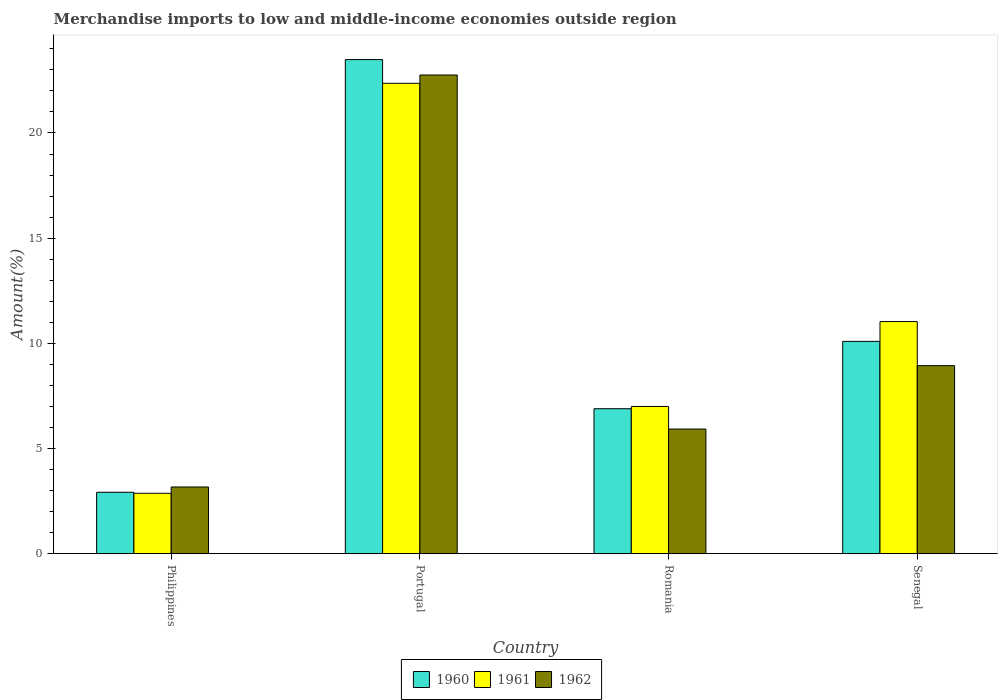Are the number of bars on each tick of the X-axis equal?
Your answer should be compact. Yes. What is the label of the 2nd group of bars from the left?
Your answer should be compact. Portugal. What is the percentage of amount earned from merchandise imports in 1962 in Portugal?
Ensure brevity in your answer.  22.76. Across all countries, what is the maximum percentage of amount earned from merchandise imports in 1960?
Give a very brief answer. 23.49. Across all countries, what is the minimum percentage of amount earned from merchandise imports in 1961?
Provide a succinct answer. 2.87. In which country was the percentage of amount earned from merchandise imports in 1960 minimum?
Offer a very short reply. Philippines. What is the total percentage of amount earned from merchandise imports in 1962 in the graph?
Provide a succinct answer. 40.79. What is the difference between the percentage of amount earned from merchandise imports in 1962 in Philippines and that in Romania?
Offer a very short reply. -2.75. What is the difference between the percentage of amount earned from merchandise imports in 1962 in Portugal and the percentage of amount earned from merchandise imports in 1960 in Philippines?
Ensure brevity in your answer.  19.84. What is the average percentage of amount earned from merchandise imports in 1961 per country?
Make the answer very short. 10.82. What is the difference between the percentage of amount earned from merchandise imports of/in 1961 and percentage of amount earned from merchandise imports of/in 1962 in Portugal?
Ensure brevity in your answer.  -0.39. In how many countries, is the percentage of amount earned from merchandise imports in 1961 greater than 23 %?
Offer a very short reply. 0. What is the ratio of the percentage of amount earned from merchandise imports in 1961 in Portugal to that in Senegal?
Provide a short and direct response. 2.03. What is the difference between the highest and the second highest percentage of amount earned from merchandise imports in 1961?
Ensure brevity in your answer.  -11.33. What is the difference between the highest and the lowest percentage of amount earned from merchandise imports in 1960?
Make the answer very short. 20.57. In how many countries, is the percentage of amount earned from merchandise imports in 1960 greater than the average percentage of amount earned from merchandise imports in 1960 taken over all countries?
Offer a very short reply. 1. Is the sum of the percentage of amount earned from merchandise imports in 1961 in Portugal and Senegal greater than the maximum percentage of amount earned from merchandise imports in 1960 across all countries?
Your response must be concise. Yes. Is it the case that in every country, the sum of the percentage of amount earned from merchandise imports in 1962 and percentage of amount earned from merchandise imports in 1960 is greater than the percentage of amount earned from merchandise imports in 1961?
Give a very brief answer. Yes. How many bars are there?
Make the answer very short. 12. Are all the bars in the graph horizontal?
Provide a succinct answer. No. How many countries are there in the graph?
Your answer should be very brief. 4. Are the values on the major ticks of Y-axis written in scientific E-notation?
Your response must be concise. No. Where does the legend appear in the graph?
Provide a short and direct response. Bottom center. What is the title of the graph?
Make the answer very short. Merchandise imports to low and middle-income economies outside region. What is the label or title of the Y-axis?
Your answer should be compact. Amount(%). What is the Amount(%) of 1960 in Philippines?
Ensure brevity in your answer.  2.92. What is the Amount(%) in 1961 in Philippines?
Offer a very short reply. 2.87. What is the Amount(%) of 1962 in Philippines?
Your answer should be very brief. 3.17. What is the Amount(%) in 1960 in Portugal?
Give a very brief answer. 23.49. What is the Amount(%) of 1961 in Portugal?
Give a very brief answer. 22.36. What is the Amount(%) of 1962 in Portugal?
Give a very brief answer. 22.76. What is the Amount(%) of 1960 in Romania?
Make the answer very short. 6.89. What is the Amount(%) in 1961 in Romania?
Provide a succinct answer. 7. What is the Amount(%) in 1962 in Romania?
Give a very brief answer. 5.92. What is the Amount(%) of 1960 in Senegal?
Ensure brevity in your answer.  10.09. What is the Amount(%) in 1961 in Senegal?
Make the answer very short. 11.03. What is the Amount(%) in 1962 in Senegal?
Offer a very short reply. 8.94. Across all countries, what is the maximum Amount(%) in 1960?
Keep it short and to the point. 23.49. Across all countries, what is the maximum Amount(%) in 1961?
Give a very brief answer. 22.36. Across all countries, what is the maximum Amount(%) in 1962?
Provide a short and direct response. 22.76. Across all countries, what is the minimum Amount(%) of 1960?
Your response must be concise. 2.92. Across all countries, what is the minimum Amount(%) of 1961?
Give a very brief answer. 2.87. Across all countries, what is the minimum Amount(%) of 1962?
Provide a succinct answer. 3.17. What is the total Amount(%) in 1960 in the graph?
Make the answer very short. 43.39. What is the total Amount(%) in 1961 in the graph?
Ensure brevity in your answer.  43.26. What is the total Amount(%) of 1962 in the graph?
Provide a succinct answer. 40.79. What is the difference between the Amount(%) of 1960 in Philippines and that in Portugal?
Give a very brief answer. -20.57. What is the difference between the Amount(%) in 1961 in Philippines and that in Portugal?
Your answer should be very brief. -19.49. What is the difference between the Amount(%) in 1962 in Philippines and that in Portugal?
Your response must be concise. -19.59. What is the difference between the Amount(%) of 1960 in Philippines and that in Romania?
Give a very brief answer. -3.97. What is the difference between the Amount(%) in 1961 in Philippines and that in Romania?
Your answer should be compact. -4.13. What is the difference between the Amount(%) of 1962 in Philippines and that in Romania?
Provide a short and direct response. -2.75. What is the difference between the Amount(%) in 1960 in Philippines and that in Senegal?
Ensure brevity in your answer.  -7.17. What is the difference between the Amount(%) of 1961 in Philippines and that in Senegal?
Provide a short and direct response. -8.16. What is the difference between the Amount(%) in 1962 in Philippines and that in Senegal?
Offer a very short reply. -5.77. What is the difference between the Amount(%) in 1960 in Portugal and that in Romania?
Your answer should be very brief. 16.6. What is the difference between the Amount(%) of 1961 in Portugal and that in Romania?
Ensure brevity in your answer.  15.36. What is the difference between the Amount(%) in 1962 in Portugal and that in Romania?
Keep it short and to the point. 16.83. What is the difference between the Amount(%) of 1960 in Portugal and that in Senegal?
Provide a succinct answer. 13.4. What is the difference between the Amount(%) in 1961 in Portugal and that in Senegal?
Provide a succinct answer. 11.33. What is the difference between the Amount(%) of 1962 in Portugal and that in Senegal?
Provide a short and direct response. 13.82. What is the difference between the Amount(%) of 1960 in Romania and that in Senegal?
Your response must be concise. -3.2. What is the difference between the Amount(%) of 1961 in Romania and that in Senegal?
Your answer should be compact. -4.04. What is the difference between the Amount(%) in 1962 in Romania and that in Senegal?
Offer a very short reply. -3.01. What is the difference between the Amount(%) in 1960 in Philippines and the Amount(%) in 1961 in Portugal?
Offer a terse response. -19.44. What is the difference between the Amount(%) in 1960 in Philippines and the Amount(%) in 1962 in Portugal?
Your answer should be very brief. -19.84. What is the difference between the Amount(%) of 1961 in Philippines and the Amount(%) of 1962 in Portugal?
Your response must be concise. -19.89. What is the difference between the Amount(%) of 1960 in Philippines and the Amount(%) of 1961 in Romania?
Offer a terse response. -4.08. What is the difference between the Amount(%) of 1960 in Philippines and the Amount(%) of 1962 in Romania?
Offer a very short reply. -3.01. What is the difference between the Amount(%) in 1961 in Philippines and the Amount(%) in 1962 in Romania?
Give a very brief answer. -3.05. What is the difference between the Amount(%) in 1960 in Philippines and the Amount(%) in 1961 in Senegal?
Ensure brevity in your answer.  -8.12. What is the difference between the Amount(%) of 1960 in Philippines and the Amount(%) of 1962 in Senegal?
Your answer should be compact. -6.02. What is the difference between the Amount(%) of 1961 in Philippines and the Amount(%) of 1962 in Senegal?
Give a very brief answer. -6.07. What is the difference between the Amount(%) in 1960 in Portugal and the Amount(%) in 1961 in Romania?
Provide a short and direct response. 16.49. What is the difference between the Amount(%) in 1960 in Portugal and the Amount(%) in 1962 in Romania?
Give a very brief answer. 17.56. What is the difference between the Amount(%) of 1961 in Portugal and the Amount(%) of 1962 in Romania?
Your answer should be compact. 16.44. What is the difference between the Amount(%) of 1960 in Portugal and the Amount(%) of 1961 in Senegal?
Offer a very short reply. 12.45. What is the difference between the Amount(%) of 1960 in Portugal and the Amount(%) of 1962 in Senegal?
Provide a short and direct response. 14.55. What is the difference between the Amount(%) of 1961 in Portugal and the Amount(%) of 1962 in Senegal?
Your answer should be very brief. 13.42. What is the difference between the Amount(%) of 1960 in Romania and the Amount(%) of 1961 in Senegal?
Provide a short and direct response. -4.14. What is the difference between the Amount(%) of 1960 in Romania and the Amount(%) of 1962 in Senegal?
Provide a short and direct response. -2.05. What is the difference between the Amount(%) of 1961 in Romania and the Amount(%) of 1962 in Senegal?
Make the answer very short. -1.94. What is the average Amount(%) of 1960 per country?
Give a very brief answer. 10.85. What is the average Amount(%) of 1961 per country?
Give a very brief answer. 10.82. What is the average Amount(%) of 1962 per country?
Provide a short and direct response. 10.2. What is the difference between the Amount(%) in 1960 and Amount(%) in 1961 in Philippines?
Offer a very short reply. 0.05. What is the difference between the Amount(%) of 1960 and Amount(%) of 1962 in Philippines?
Your answer should be very brief. -0.25. What is the difference between the Amount(%) in 1961 and Amount(%) in 1962 in Philippines?
Ensure brevity in your answer.  -0.3. What is the difference between the Amount(%) in 1960 and Amount(%) in 1961 in Portugal?
Keep it short and to the point. 1.13. What is the difference between the Amount(%) in 1960 and Amount(%) in 1962 in Portugal?
Ensure brevity in your answer.  0.73. What is the difference between the Amount(%) of 1961 and Amount(%) of 1962 in Portugal?
Offer a terse response. -0.39. What is the difference between the Amount(%) in 1960 and Amount(%) in 1961 in Romania?
Keep it short and to the point. -0.11. What is the difference between the Amount(%) of 1960 and Amount(%) of 1962 in Romania?
Your answer should be compact. 0.97. What is the difference between the Amount(%) of 1961 and Amount(%) of 1962 in Romania?
Offer a very short reply. 1.07. What is the difference between the Amount(%) in 1960 and Amount(%) in 1961 in Senegal?
Make the answer very short. -0.94. What is the difference between the Amount(%) in 1960 and Amount(%) in 1962 in Senegal?
Your answer should be compact. 1.16. What is the difference between the Amount(%) in 1961 and Amount(%) in 1962 in Senegal?
Offer a terse response. 2.1. What is the ratio of the Amount(%) of 1960 in Philippines to that in Portugal?
Provide a succinct answer. 0.12. What is the ratio of the Amount(%) in 1961 in Philippines to that in Portugal?
Give a very brief answer. 0.13. What is the ratio of the Amount(%) of 1962 in Philippines to that in Portugal?
Your answer should be very brief. 0.14. What is the ratio of the Amount(%) of 1960 in Philippines to that in Romania?
Your answer should be compact. 0.42. What is the ratio of the Amount(%) of 1961 in Philippines to that in Romania?
Provide a succinct answer. 0.41. What is the ratio of the Amount(%) in 1962 in Philippines to that in Romania?
Your answer should be very brief. 0.54. What is the ratio of the Amount(%) of 1960 in Philippines to that in Senegal?
Your answer should be compact. 0.29. What is the ratio of the Amount(%) of 1961 in Philippines to that in Senegal?
Keep it short and to the point. 0.26. What is the ratio of the Amount(%) in 1962 in Philippines to that in Senegal?
Make the answer very short. 0.35. What is the ratio of the Amount(%) in 1960 in Portugal to that in Romania?
Make the answer very short. 3.41. What is the ratio of the Amount(%) in 1961 in Portugal to that in Romania?
Provide a succinct answer. 3.2. What is the ratio of the Amount(%) in 1962 in Portugal to that in Romania?
Give a very brief answer. 3.84. What is the ratio of the Amount(%) of 1960 in Portugal to that in Senegal?
Offer a terse response. 2.33. What is the ratio of the Amount(%) in 1961 in Portugal to that in Senegal?
Your answer should be very brief. 2.03. What is the ratio of the Amount(%) of 1962 in Portugal to that in Senegal?
Keep it short and to the point. 2.55. What is the ratio of the Amount(%) of 1960 in Romania to that in Senegal?
Your answer should be very brief. 0.68. What is the ratio of the Amount(%) in 1961 in Romania to that in Senegal?
Give a very brief answer. 0.63. What is the ratio of the Amount(%) of 1962 in Romania to that in Senegal?
Provide a short and direct response. 0.66. What is the difference between the highest and the second highest Amount(%) of 1960?
Your answer should be very brief. 13.4. What is the difference between the highest and the second highest Amount(%) in 1961?
Give a very brief answer. 11.33. What is the difference between the highest and the second highest Amount(%) in 1962?
Your answer should be compact. 13.82. What is the difference between the highest and the lowest Amount(%) in 1960?
Your answer should be very brief. 20.57. What is the difference between the highest and the lowest Amount(%) in 1961?
Ensure brevity in your answer.  19.49. What is the difference between the highest and the lowest Amount(%) in 1962?
Your answer should be very brief. 19.59. 